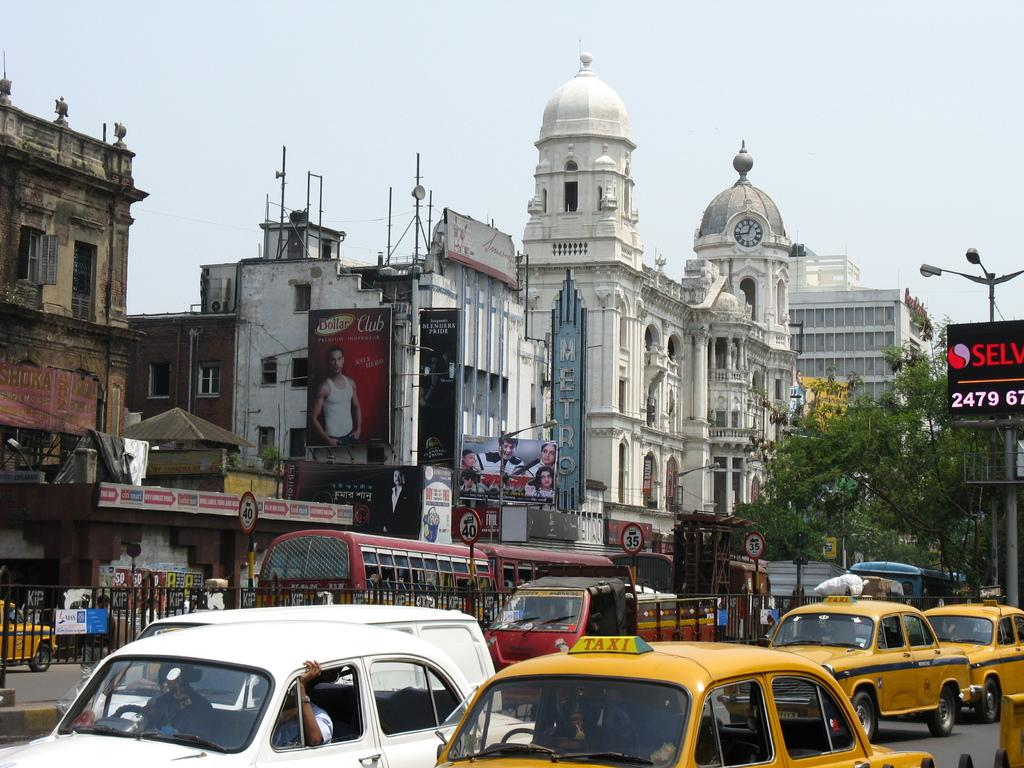<image>
Write a terse but informative summary of the picture. three taxi cabs are driving down a busy street. 